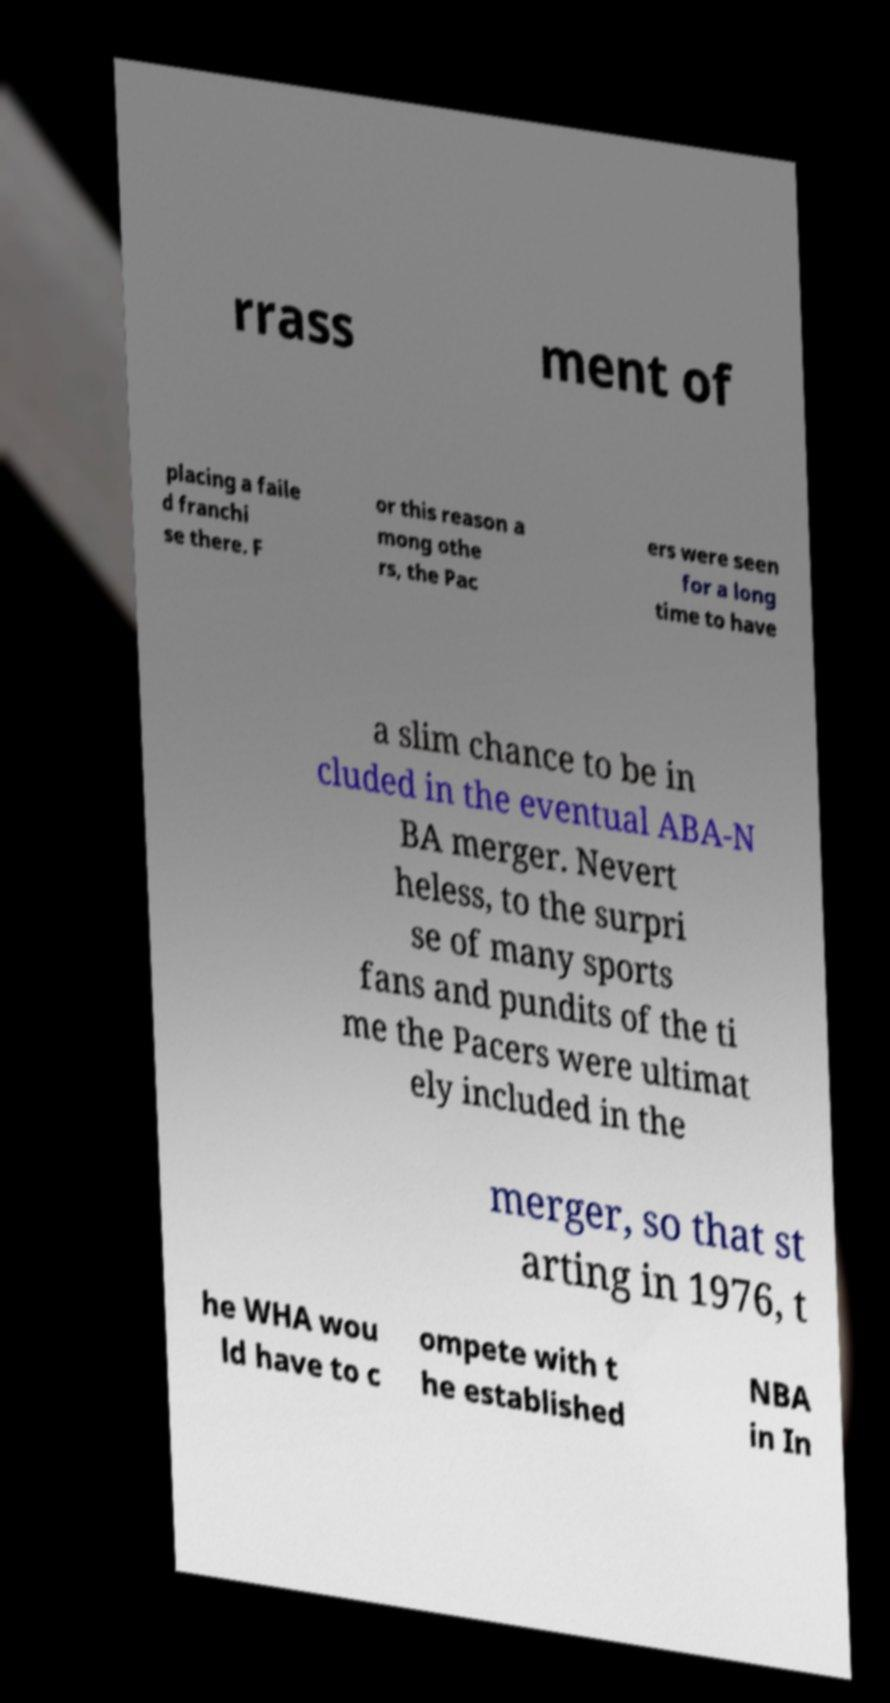There's text embedded in this image that I need extracted. Can you transcribe it verbatim? rrass ment of placing a faile d franchi se there. F or this reason a mong othe rs, the Pac ers were seen for a long time to have a slim chance to be in cluded in the eventual ABA-N BA merger. Nevert heless, to the surpri se of many sports fans and pundits of the ti me the Pacers were ultimat ely included in the merger, so that st arting in 1976, t he WHA wou ld have to c ompete with t he established NBA in In 